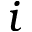<formula> <loc_0><loc_0><loc_500><loc_500>i</formula> 